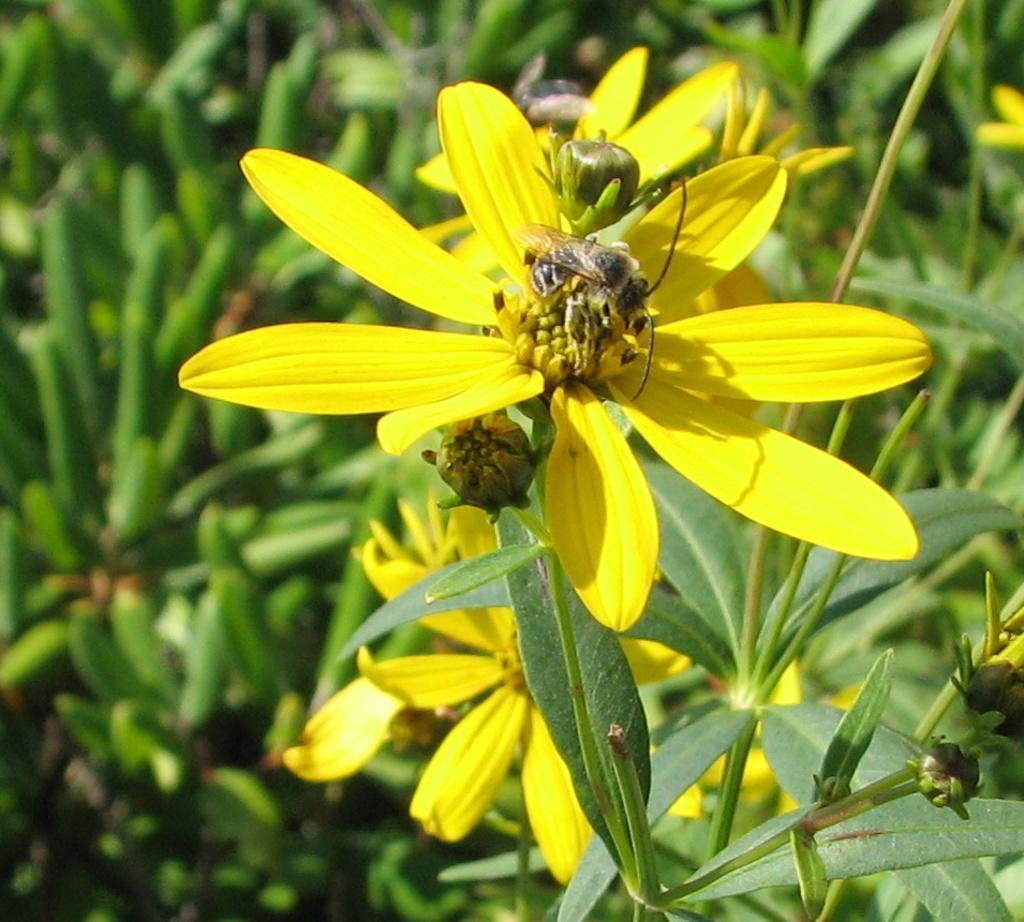Can you describe this image briefly? In this image I can see flowers in yellow color, background I can see leaves in green color. 